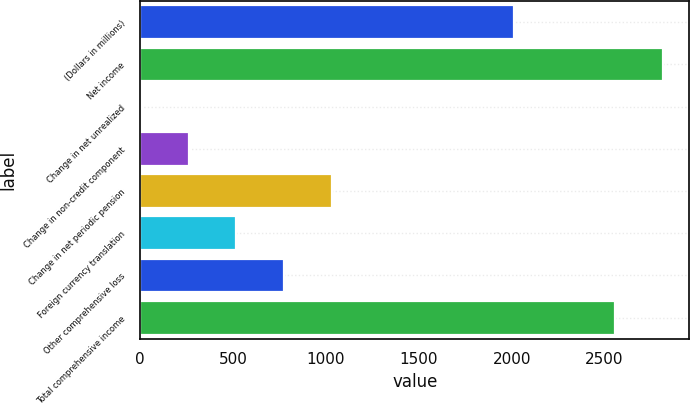Convert chart. <chart><loc_0><loc_0><loc_500><loc_500><bar_chart><fcel>(Dollars in millions)<fcel>Net income<fcel>Change in net unrealized<fcel>Change in non-credit component<fcel>Change in net periodic pension<fcel>Foreign currency translation<fcel>Other comprehensive loss<fcel>Total comprehensive income<nl><fcel>2014<fcel>2815.01<fcel>3.6<fcel>260.21<fcel>1030.04<fcel>516.82<fcel>773.43<fcel>2558.4<nl></chart> 